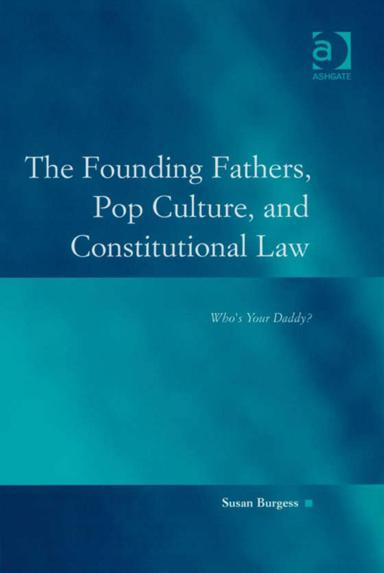Which publisher released this book? The informative work titled 'The Founding Fathers, Pop Culture, and Constitutional Law: Who's Your Daddy?' was published by Ashgate, a company known for its scholastic contributions in the fields of academic publishing. 